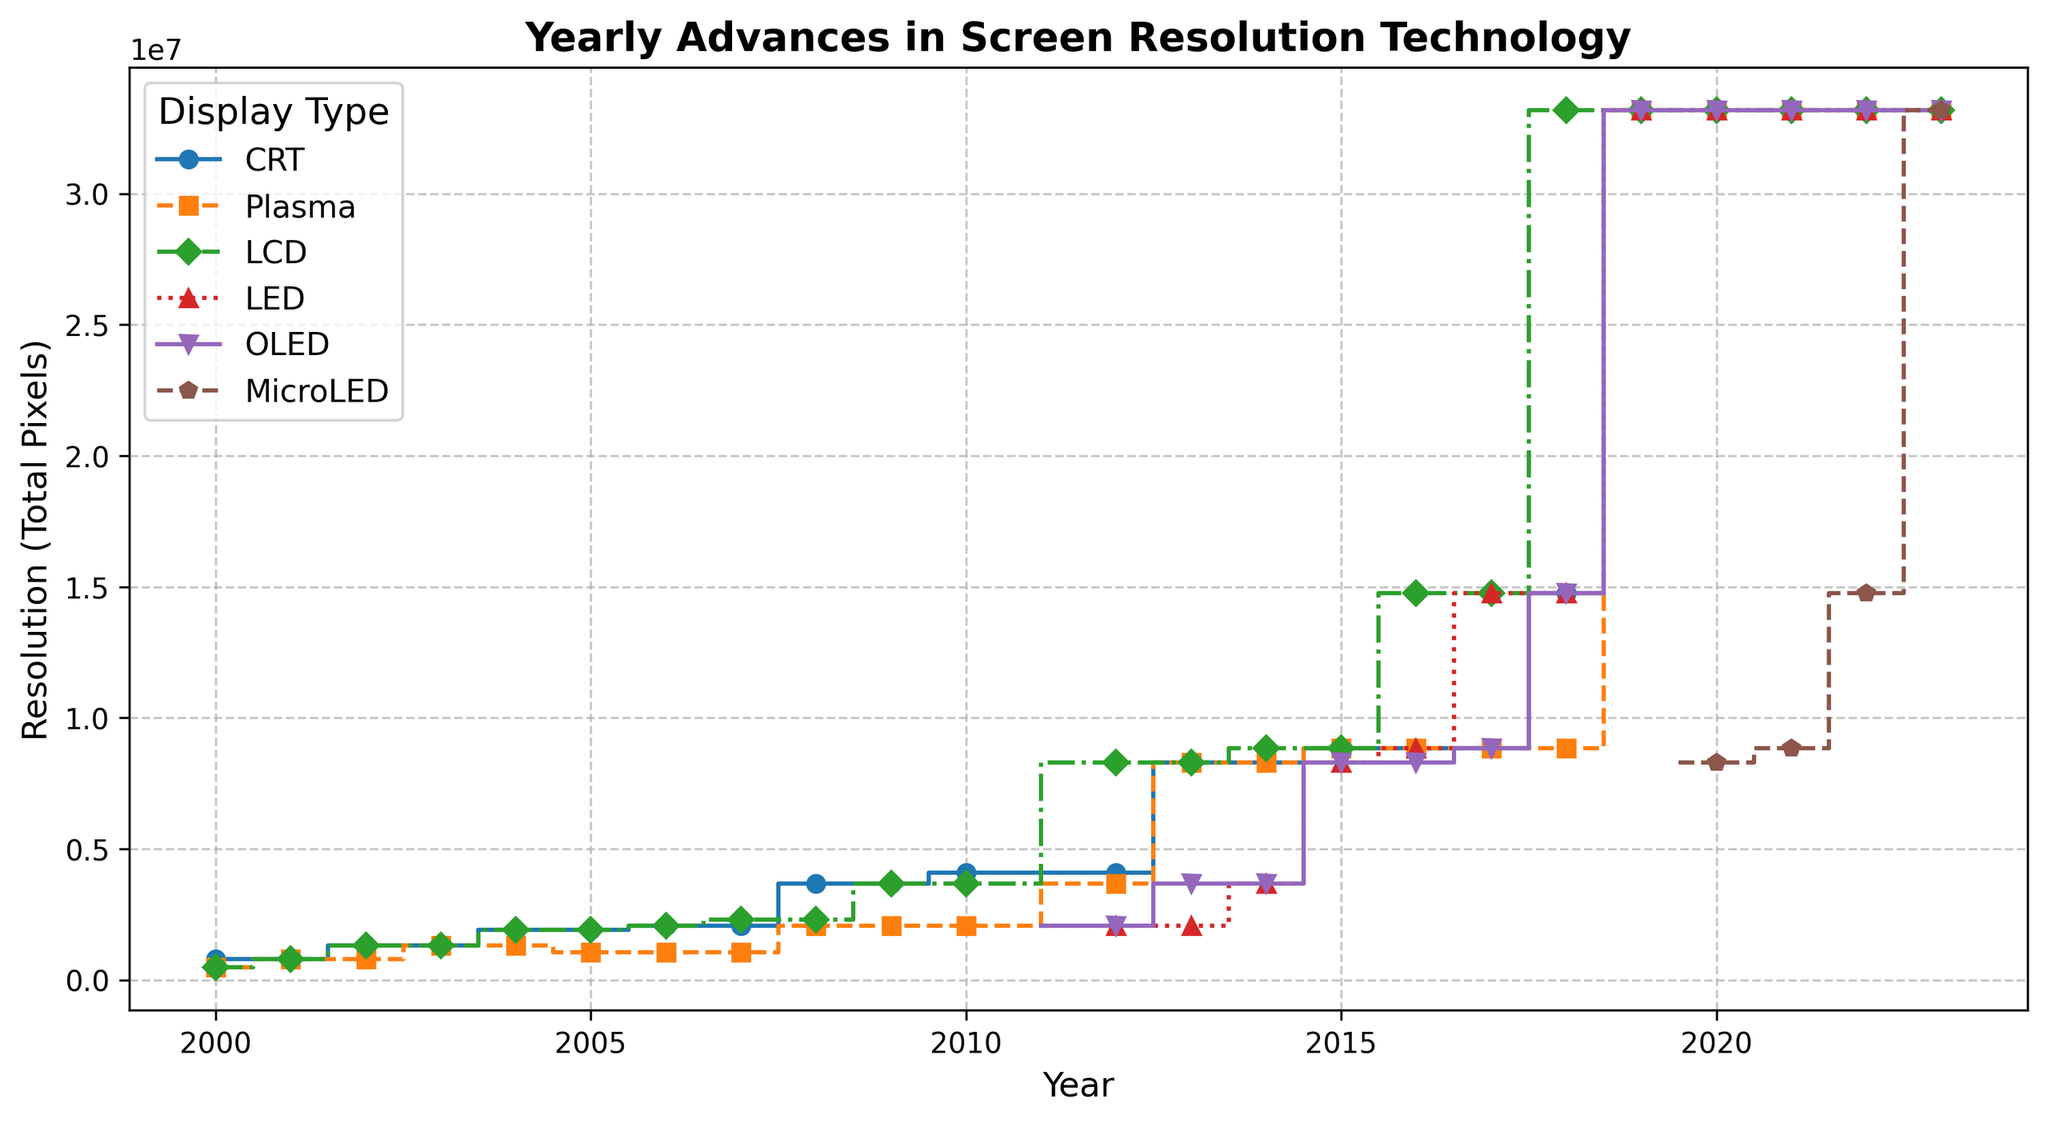Which display type first reached a resolution of 3840x2160? By looking at the steps, find the point where each display type line first reaches 3840x2160. For LCD and Plasma, it happens in 2012, while LED reached it in 2012, OLED in 2013, and MicroLED in 2023.
Answer: Plasma Which display type had the highest resolution in 2006? Look at the y-values corresponding to 2006 for each display type, and compare them. CRT and LCD reached 1920x1080, while Plasma had 1366x768.
Answer: CRT and LCD In which year did OLED first achieve a resolution higher than 2560x1440? Trace the steps of the OLED stair plot and identify the year where the resolution steps above 2560x1440. This happens in 2013 when it reaches 3840x2160.
Answer: 2013 Compare LED and Plasma display types in the year 2007. Which one had a higher resolution, and by how much? Lookup the step value for both LED and Plasma in 2007, where LED is 1920x1200 and Plasma is 1366x768. The difference is 1920x1200 - 1366x768 = 553344 pixels.
Answer: LED by 553344 pixels What was the first year MicroLED achieved a resolution, and what was it? Find the first year with a visible step for MicroLED. This occurs in 2020 when its resolution first appears at 3840x2160.
Answer: 2020, 3840x2160 Which display type showed the most significant resolution increase between any two consecutive years? Identify the steps with the most considerable vertical gaps between consecutive years. One notable example is LCD between 2011 and 2012, which jumps from 2560x1600 to 3840x2160, an increase of 4390960 pixels.
Answer: LCD between 2011 and 2012 How many display types reached 7680x4320 in 2023? Count the number of display type lines that achieve a resolution of 7680x4320 in 2023. This is achieved by LCD, Plasma, LED, OLED, and MicroLED.
Answer: 4 display types Which year saw the introduction of 5120x2880 resolution in LCD display? Look for the point where the LCD stair plot first steps to 5120x2880, which happens in 2016.
Answer: 2016 What is the trend for Plasma display resolution from 2008 to 2023? Trace the steps of the Plasma stair plot from 2008 to 2023. Plasma resolution stays constant from 2008 to 2011, increases significantly in 2012, stays constant, and reaches 7680x4320 consistently from 2019 onwards.
Answer: Increasing trend with significant jumps Compare the resolution trajectories of LED and OLED from 2015 to 2023. What is noticeable? Follow the steps for LED and OLED from 2015 to 2023. Both start at 3840x2160 in 2015, with OLED having a slightly higher initial step. They both jump in 2018 and stabilize at 7680x4320 in later years.
Answer: Both trajectories show significant jumps and stabilization around 7680x4320 